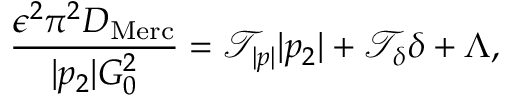<formula> <loc_0><loc_0><loc_500><loc_500>\frac { \epsilon ^ { 2 } \pi ^ { 2 } D _ { M e r c } } { | p _ { 2 } | G _ { 0 } ^ { 2 } } = \mathcal { T } _ { | p | } | p _ { 2 } | + \mathcal { T } _ { \delta } \delta + \Lambda ,</formula> 